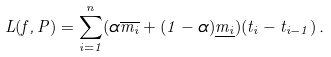<formula> <loc_0><loc_0><loc_500><loc_500>L ( f , P ) = \sum _ { i = 1 } ^ { n } ( \alpha \overline { m _ { i } } + ( 1 - \alpha ) \underline { m _ { i } } ) ( t _ { i } - t _ { i - 1 } ) \, .</formula> 